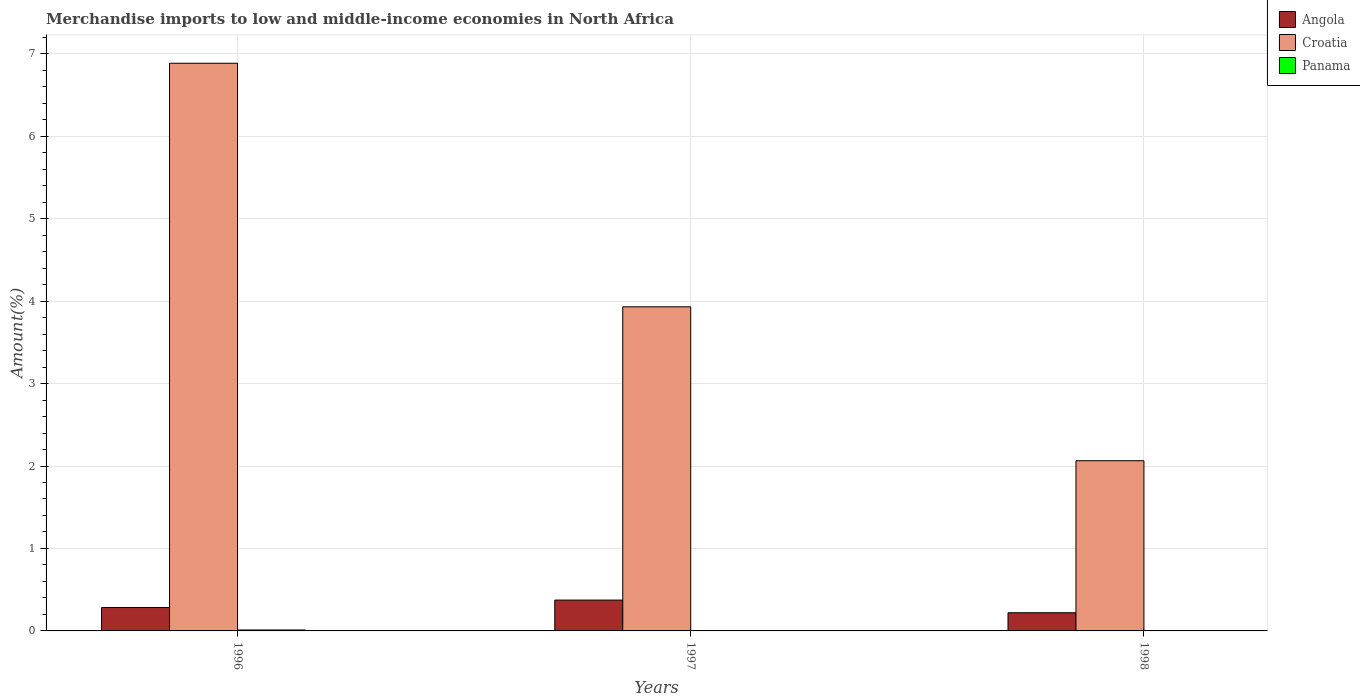How many groups of bars are there?
Offer a terse response. 3. What is the label of the 3rd group of bars from the left?
Provide a short and direct response. 1998. In how many cases, is the number of bars for a given year not equal to the number of legend labels?
Offer a terse response. 0. What is the percentage of amount earned from merchandise imports in Panama in 1996?
Offer a terse response. 0.01. Across all years, what is the maximum percentage of amount earned from merchandise imports in Panama?
Give a very brief answer. 0.01. Across all years, what is the minimum percentage of amount earned from merchandise imports in Angola?
Make the answer very short. 0.22. What is the total percentage of amount earned from merchandise imports in Croatia in the graph?
Provide a succinct answer. 12.88. What is the difference between the percentage of amount earned from merchandise imports in Croatia in 1996 and that in 1997?
Offer a very short reply. 2.95. What is the difference between the percentage of amount earned from merchandise imports in Croatia in 1998 and the percentage of amount earned from merchandise imports in Angola in 1996?
Offer a terse response. 1.78. What is the average percentage of amount earned from merchandise imports in Croatia per year?
Ensure brevity in your answer.  4.29. In the year 1997, what is the difference between the percentage of amount earned from merchandise imports in Panama and percentage of amount earned from merchandise imports in Angola?
Offer a very short reply. -0.37. In how many years, is the percentage of amount earned from merchandise imports in Croatia greater than 6.4 %?
Keep it short and to the point. 1. What is the ratio of the percentage of amount earned from merchandise imports in Panama in 1997 to that in 1998?
Give a very brief answer. 3.03. Is the difference between the percentage of amount earned from merchandise imports in Panama in 1996 and 1997 greater than the difference between the percentage of amount earned from merchandise imports in Angola in 1996 and 1997?
Your response must be concise. Yes. What is the difference between the highest and the second highest percentage of amount earned from merchandise imports in Panama?
Your answer should be very brief. 0.01. What is the difference between the highest and the lowest percentage of amount earned from merchandise imports in Angola?
Your answer should be compact. 0.15. In how many years, is the percentage of amount earned from merchandise imports in Panama greater than the average percentage of amount earned from merchandise imports in Panama taken over all years?
Your answer should be compact. 1. Is the sum of the percentage of amount earned from merchandise imports in Panama in 1996 and 1997 greater than the maximum percentage of amount earned from merchandise imports in Croatia across all years?
Your answer should be compact. No. What does the 2nd bar from the left in 1996 represents?
Make the answer very short. Croatia. What does the 1st bar from the right in 1996 represents?
Your answer should be very brief. Panama. Is it the case that in every year, the sum of the percentage of amount earned from merchandise imports in Angola and percentage of amount earned from merchandise imports in Croatia is greater than the percentage of amount earned from merchandise imports in Panama?
Offer a very short reply. Yes. How many bars are there?
Offer a very short reply. 9. What is the difference between two consecutive major ticks on the Y-axis?
Your answer should be compact. 1. Does the graph contain grids?
Offer a terse response. Yes. How many legend labels are there?
Offer a very short reply. 3. How are the legend labels stacked?
Keep it short and to the point. Vertical. What is the title of the graph?
Ensure brevity in your answer.  Merchandise imports to low and middle-income economies in North Africa. Does "Ukraine" appear as one of the legend labels in the graph?
Your answer should be very brief. No. What is the label or title of the Y-axis?
Give a very brief answer. Amount(%). What is the Amount(%) in Angola in 1996?
Your response must be concise. 0.28. What is the Amount(%) of Croatia in 1996?
Make the answer very short. 6.88. What is the Amount(%) in Panama in 1996?
Provide a short and direct response. 0.01. What is the Amount(%) in Angola in 1997?
Keep it short and to the point. 0.37. What is the Amount(%) of Croatia in 1997?
Your answer should be compact. 3.93. What is the Amount(%) of Panama in 1997?
Offer a terse response. 0. What is the Amount(%) in Angola in 1998?
Your answer should be very brief. 0.22. What is the Amount(%) of Croatia in 1998?
Give a very brief answer. 2.06. What is the Amount(%) of Panama in 1998?
Ensure brevity in your answer.  0. Across all years, what is the maximum Amount(%) in Angola?
Keep it short and to the point. 0.37. Across all years, what is the maximum Amount(%) in Croatia?
Offer a terse response. 6.88. Across all years, what is the maximum Amount(%) of Panama?
Offer a terse response. 0.01. Across all years, what is the minimum Amount(%) in Angola?
Your answer should be very brief. 0.22. Across all years, what is the minimum Amount(%) in Croatia?
Your response must be concise. 2.06. Across all years, what is the minimum Amount(%) of Panama?
Provide a succinct answer. 0. What is the total Amount(%) of Angola in the graph?
Give a very brief answer. 0.88. What is the total Amount(%) of Croatia in the graph?
Give a very brief answer. 12.88. What is the total Amount(%) of Panama in the graph?
Provide a succinct answer. 0.01. What is the difference between the Amount(%) in Angola in 1996 and that in 1997?
Offer a terse response. -0.09. What is the difference between the Amount(%) in Croatia in 1996 and that in 1997?
Offer a terse response. 2.95. What is the difference between the Amount(%) in Panama in 1996 and that in 1997?
Your answer should be very brief. 0.01. What is the difference between the Amount(%) of Angola in 1996 and that in 1998?
Your answer should be compact. 0.06. What is the difference between the Amount(%) of Croatia in 1996 and that in 1998?
Offer a terse response. 4.82. What is the difference between the Amount(%) of Panama in 1996 and that in 1998?
Provide a short and direct response. 0.01. What is the difference between the Amount(%) of Angola in 1997 and that in 1998?
Provide a short and direct response. 0.15. What is the difference between the Amount(%) of Croatia in 1997 and that in 1998?
Your answer should be very brief. 1.87. What is the difference between the Amount(%) of Panama in 1997 and that in 1998?
Provide a short and direct response. 0. What is the difference between the Amount(%) in Angola in 1996 and the Amount(%) in Croatia in 1997?
Make the answer very short. -3.65. What is the difference between the Amount(%) in Angola in 1996 and the Amount(%) in Panama in 1997?
Keep it short and to the point. 0.28. What is the difference between the Amount(%) of Croatia in 1996 and the Amount(%) of Panama in 1997?
Make the answer very short. 6.88. What is the difference between the Amount(%) in Angola in 1996 and the Amount(%) in Croatia in 1998?
Your response must be concise. -1.78. What is the difference between the Amount(%) in Angola in 1996 and the Amount(%) in Panama in 1998?
Provide a succinct answer. 0.28. What is the difference between the Amount(%) of Croatia in 1996 and the Amount(%) of Panama in 1998?
Give a very brief answer. 6.88. What is the difference between the Amount(%) of Angola in 1997 and the Amount(%) of Croatia in 1998?
Your answer should be very brief. -1.69. What is the difference between the Amount(%) in Angola in 1997 and the Amount(%) in Panama in 1998?
Make the answer very short. 0.37. What is the difference between the Amount(%) of Croatia in 1997 and the Amount(%) of Panama in 1998?
Offer a terse response. 3.93. What is the average Amount(%) in Angola per year?
Give a very brief answer. 0.29. What is the average Amount(%) of Croatia per year?
Make the answer very short. 4.29. What is the average Amount(%) of Panama per year?
Your answer should be compact. 0. In the year 1996, what is the difference between the Amount(%) of Angola and Amount(%) of Croatia?
Provide a succinct answer. -6.6. In the year 1996, what is the difference between the Amount(%) of Angola and Amount(%) of Panama?
Provide a succinct answer. 0.27. In the year 1996, what is the difference between the Amount(%) of Croatia and Amount(%) of Panama?
Your answer should be compact. 6.87. In the year 1997, what is the difference between the Amount(%) of Angola and Amount(%) of Croatia?
Ensure brevity in your answer.  -3.56. In the year 1997, what is the difference between the Amount(%) in Angola and Amount(%) in Panama?
Provide a short and direct response. 0.37. In the year 1997, what is the difference between the Amount(%) of Croatia and Amount(%) of Panama?
Provide a short and direct response. 3.93. In the year 1998, what is the difference between the Amount(%) in Angola and Amount(%) in Croatia?
Offer a terse response. -1.84. In the year 1998, what is the difference between the Amount(%) in Angola and Amount(%) in Panama?
Provide a succinct answer. 0.22. In the year 1998, what is the difference between the Amount(%) of Croatia and Amount(%) of Panama?
Provide a short and direct response. 2.06. What is the ratio of the Amount(%) of Angola in 1996 to that in 1997?
Keep it short and to the point. 0.76. What is the ratio of the Amount(%) of Croatia in 1996 to that in 1997?
Provide a succinct answer. 1.75. What is the ratio of the Amount(%) in Panama in 1996 to that in 1997?
Your answer should be compact. 23.54. What is the ratio of the Amount(%) in Angola in 1996 to that in 1998?
Give a very brief answer. 1.29. What is the ratio of the Amount(%) in Croatia in 1996 to that in 1998?
Offer a very short reply. 3.34. What is the ratio of the Amount(%) in Panama in 1996 to that in 1998?
Keep it short and to the point. 71.27. What is the ratio of the Amount(%) of Angola in 1997 to that in 1998?
Your answer should be very brief. 1.7. What is the ratio of the Amount(%) in Croatia in 1997 to that in 1998?
Keep it short and to the point. 1.9. What is the ratio of the Amount(%) in Panama in 1997 to that in 1998?
Make the answer very short. 3.03. What is the difference between the highest and the second highest Amount(%) in Angola?
Offer a terse response. 0.09. What is the difference between the highest and the second highest Amount(%) in Croatia?
Give a very brief answer. 2.95. What is the difference between the highest and the second highest Amount(%) of Panama?
Ensure brevity in your answer.  0.01. What is the difference between the highest and the lowest Amount(%) in Angola?
Your answer should be very brief. 0.15. What is the difference between the highest and the lowest Amount(%) in Croatia?
Make the answer very short. 4.82. What is the difference between the highest and the lowest Amount(%) in Panama?
Your answer should be very brief. 0.01. 